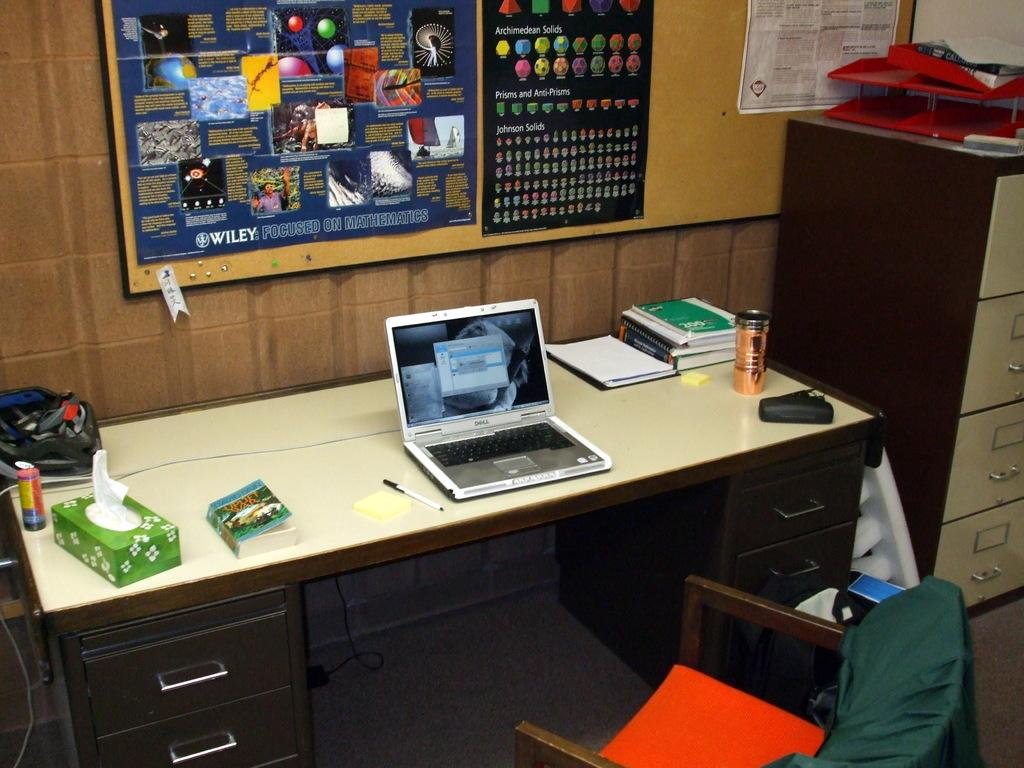<image>
Write a terse but informative summary of the picture. Student's desk with posted of "Archimedean Solids" and other Solids on the wall. 